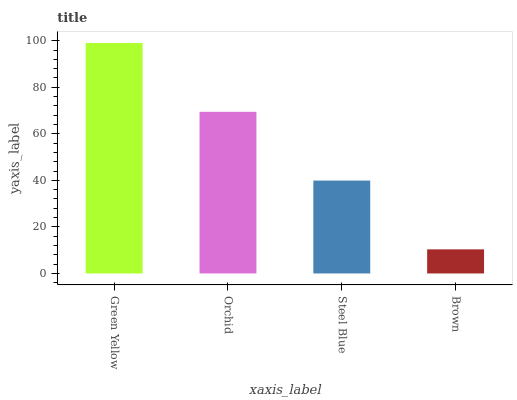Is Brown the minimum?
Answer yes or no. Yes. Is Green Yellow the maximum?
Answer yes or no. Yes. Is Orchid the minimum?
Answer yes or no. No. Is Orchid the maximum?
Answer yes or no. No. Is Green Yellow greater than Orchid?
Answer yes or no. Yes. Is Orchid less than Green Yellow?
Answer yes or no. Yes. Is Orchid greater than Green Yellow?
Answer yes or no. No. Is Green Yellow less than Orchid?
Answer yes or no. No. Is Orchid the high median?
Answer yes or no. Yes. Is Steel Blue the low median?
Answer yes or no. Yes. Is Green Yellow the high median?
Answer yes or no. No. Is Orchid the low median?
Answer yes or no. No. 